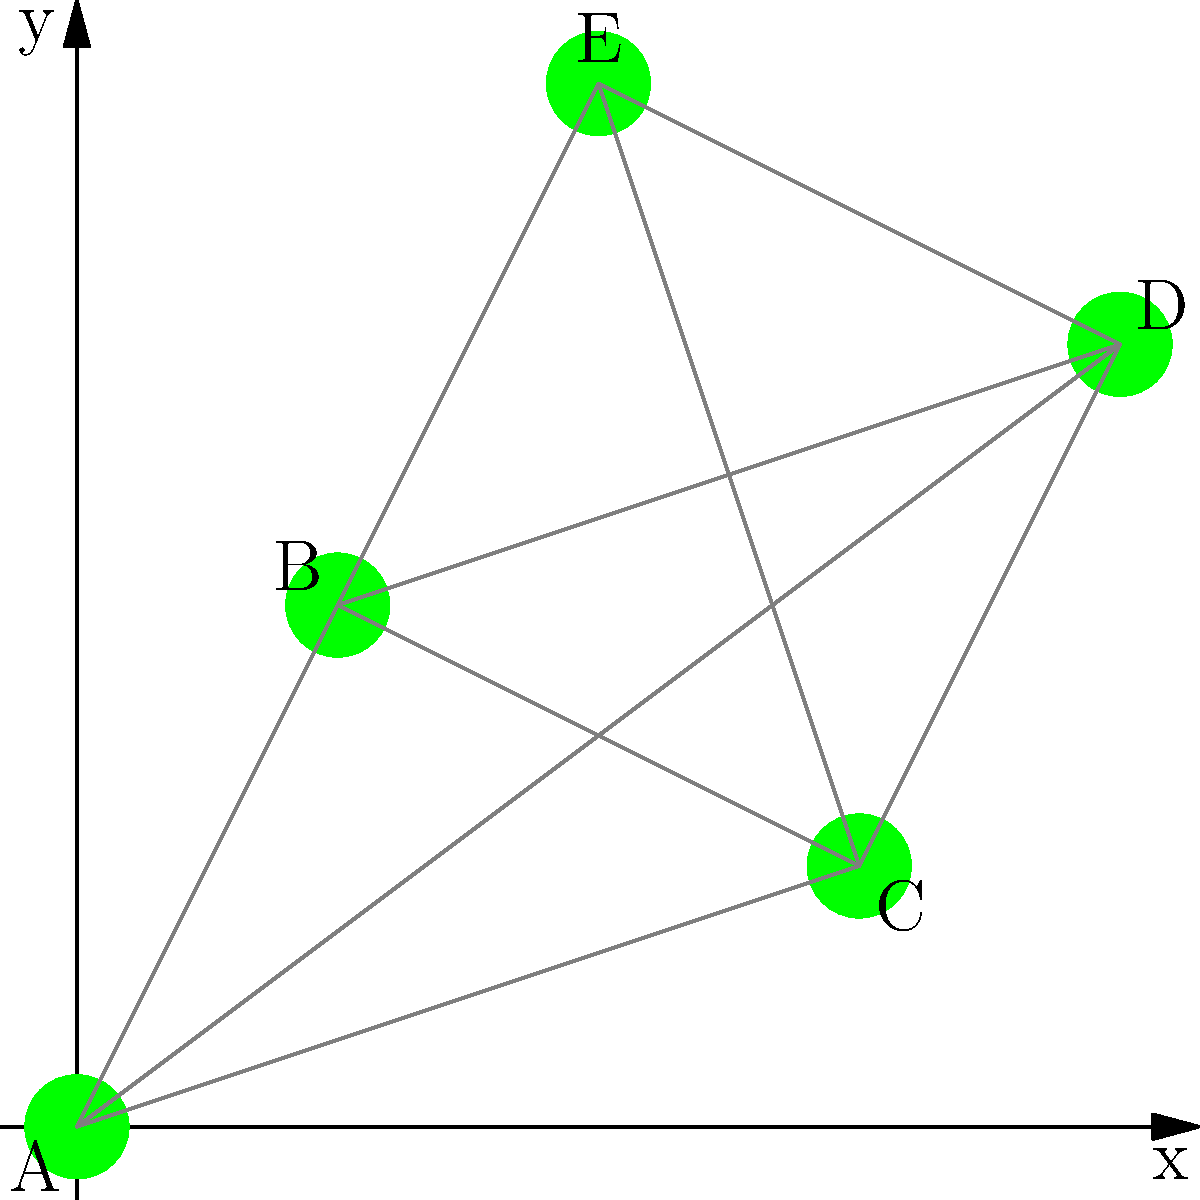As a farmer looking to optimize your operations, you need to determine the shortest route for your farm equipment to cover all fields in your complex farm layout. The diagram shows five fields (A, B, C, D, and E) represented as nodes in a graph. The distances between fields are proportional to their Euclidean distances on the graph. What is the length of the shortest possible route that visits all fields exactly once and returns to the starting point? To solve this problem, we need to find the shortest Hamiltonian cycle in the graph, which is known as the Traveling Salesman Problem (TSP). Here's a step-by-step approach:

1) First, calculate the distances between all pairs of fields using the Euclidean distance formula:
   $d = \sqrt{(x_2-x_1)^2 + (y_2-y_1)^2}$

2) Create a distance matrix:
   $$\begin{matrix}
   & A & B & C & D & E \\
   A & 0 & 2.24 & 3.16 & 5 & 4.47 \\
   B & 2.24 & 0 & 2.24 & 3.16 & 2.24 \\
   C & 3.16 & 2.24 & 0 & 2.24 & 3.16 \\
   D & 5 & 3.16 & 2.24 & 0 & 2.24 \\
   E & 4.47 & 2.24 & 3.16 & 2.24 & 0
   \end{matrix}$$

3) For a small number of nodes like this, we can use the brute-force method to find the shortest cycle. There are $(5-1)! = 24$ possible routes.

4) Calculate the length of each possible route and find the shortest one. The shortest route is:
   A → B → E → D → C → A

5) Calculate the total length of this route:
   $2.24 + 2.24 + 2.24 + 2.24 + 3.16 = 12.12$

Therefore, the length of the shortest route that visits all fields exactly once and returns to the starting point is approximately 12.12 units.
Answer: 12.12 units 